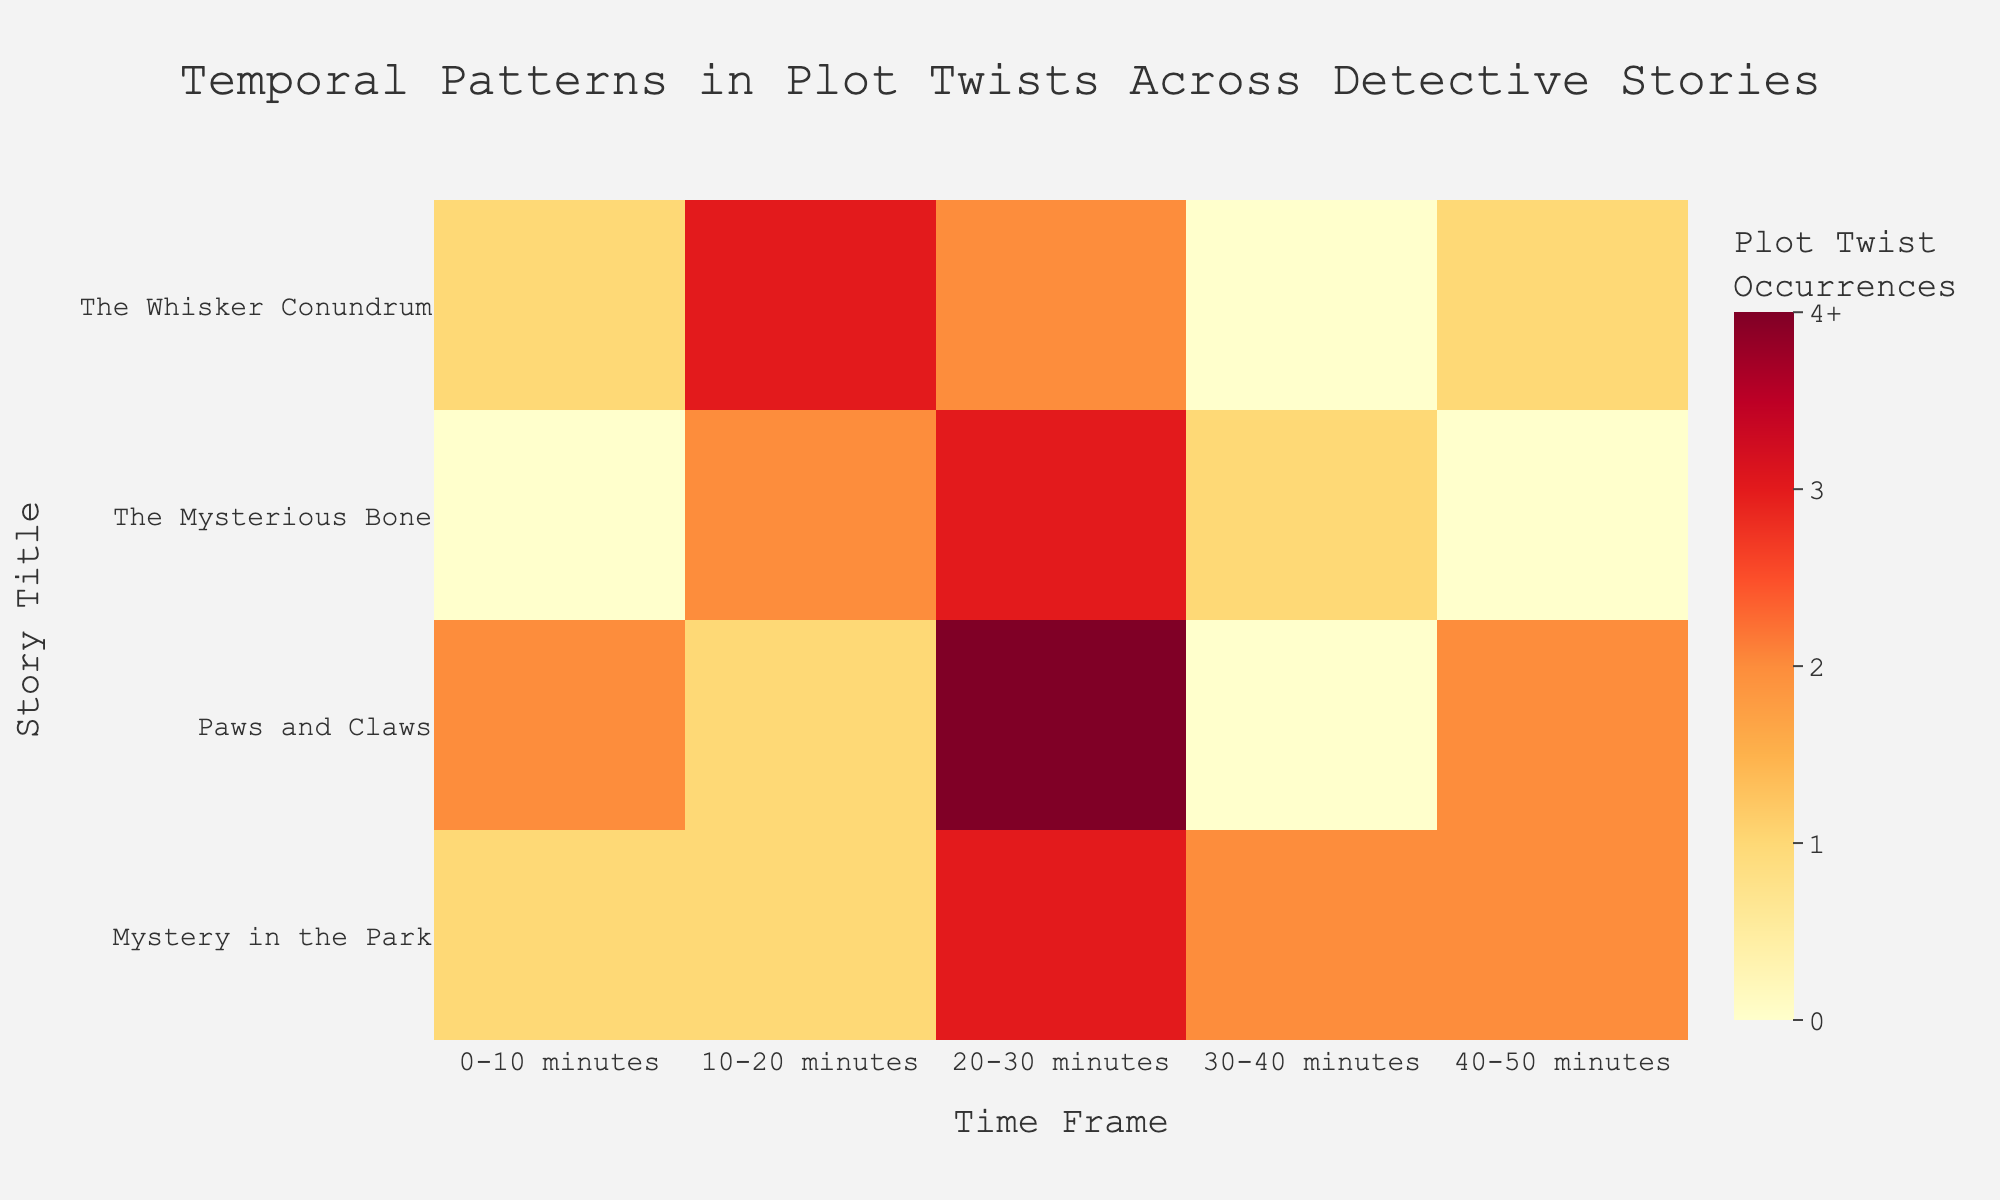What's the title of the figure? The title is prominently displayed at the top center of the figure. It reads "Temporal Patterns in Plot Twists Across Detective Stories"
Answer: Temporal Patterns in Plot Twists Across Detective Stories Which story has the highest number of plot twists in the 20-30 minute time frame? Check each story's plot twist occurrences in the 20-30 minute time frame. "Paws and Claws" has 4, which is the highest among all stories in that time frame
Answer: Paws and Claws How many plot twists occur in "The Whisker Conundrum" between 0-20 minutes? Summing the occurrences in the "0-10 minutes" (1) and "10-20 minutes" (3) time frames for "The Whisker Conundrum," we get 1 + 3 = 4
Answer: 4 Which story has the smallest range of plot twists across all time frames? Find the difference between the highest and lowest number of plot twists for each story. "The Whisker Conundrum" ranges from 0 to 3, "The Mysterious Bone" from 0 to 3, "Paws and Claws" from 0 to 4, and "Mystery in the Park" from 1 to 3. The minimal range is 2 for "Mystery in the Park"
Answer: Mystery in the Park Do any time frames have the same number of plot twists across all stories? Check each time frame row in the heatmap to see if all plot twist values are identical across the stories. No single time frame has identical plot twist occurrences across all stories
Answer: No Which story has the most variable plot twist occurrences across the time frames? "The Whisker Conundrum" ranges between 0 and 3 twists, "The Mysterious Bone" between 0 and 3, "Paws and Claws" between 0 and 4, and "Mystery in the Park" between 1 and 3. The highest variability is in "Paws and Claws"
Answer: Paws and Claws During which time frame does "The Mysterious Bone" have the highest number of plot twists? Observe the "The Mysterious Bone" row and find the maximum value. Highest plot twists are during 20-30 minutes with 3 occurrences
Answer: 20-30 minutes In which time frames does "Paws and Claws" have no plot twists? Scan the "Paws and Claws" row and note times with 0 twists. The "30-40 minutes" time frame has 0 plot twists
Answer: 30-40 minutes Which story has the most plot twists occurring in the last time frame (40-50 minutes)? Compare the plot twists in the "40-50 minutes" column for each story. Both "Paws and Claws" and "Mystery in the Park" have 2, the highest in that frame
Answer: Paws and Claws, Mystery in the Park What's the total number of plot twists in "The Mysterious Bone" for the entire duration? Add up plot twists across all time frames for "The Mysterious Bone": 0 + 2 + 3 + 1 + 0 = 6
Answer: 6 